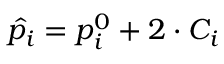<formula> <loc_0><loc_0><loc_500><loc_500>\hat { p _ { i } } = p _ { i } ^ { 0 } + 2 \cdot C _ { i }</formula> 